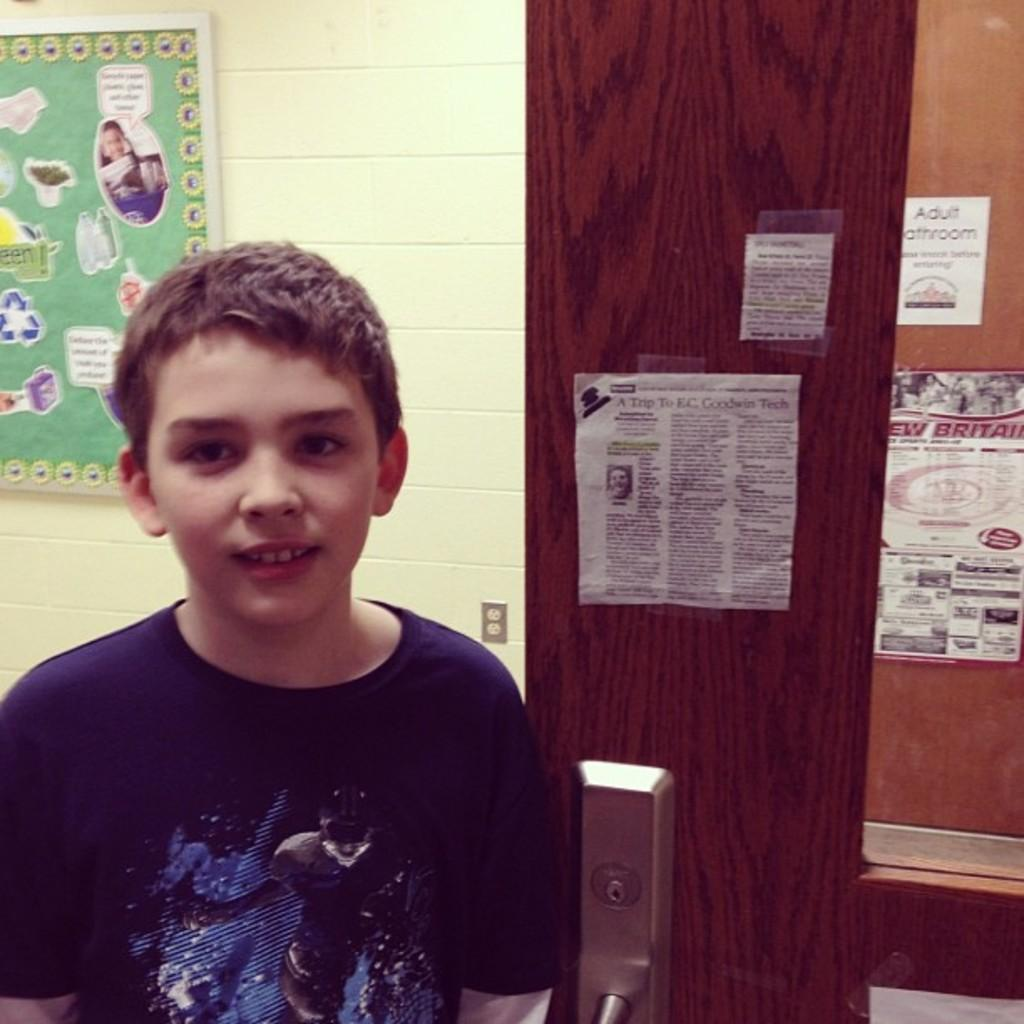What is the main subject of the image? There is a person standing in the image. What can be seen attached to the wall in the image? There is a board attached to the wall in the image. What is attached to the door in the image? There are pamphlets attached to the door in the image. What type of alarm can be heard going off in the image? There is no alarm present or going off in the image. How does the curtain contribute to the scene in the image? There is no curtain present in the image. 